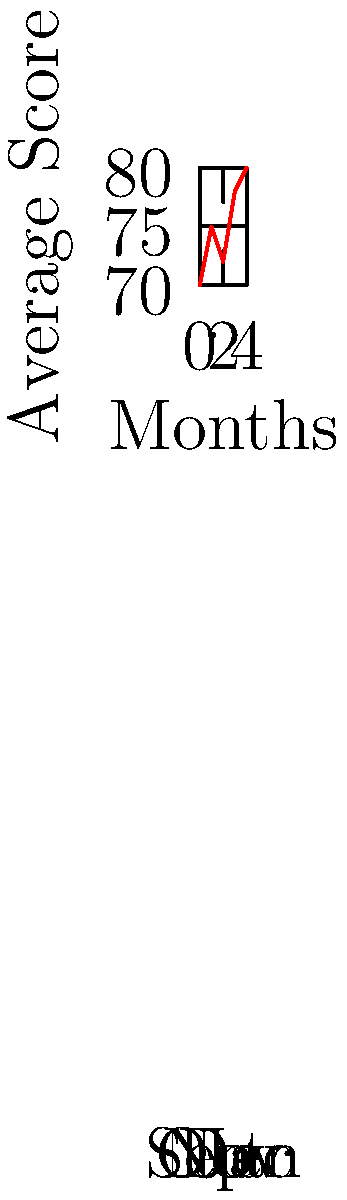The line graph shows the average score of your students over five months. What was the increase in the average score from September to January? To find the increase in average score from September to January, we need to:

1. Identify the average score in September (first month):
   September average score = 70

2. Identify the average score in January (last month):
   January average score = 80

3. Calculate the difference between January and September scores:
   Increase = January score - September score
   Increase = 80 - 70 = 10

Therefore, the increase in the average score from September to January is 10 points.
Answer: 10 points 